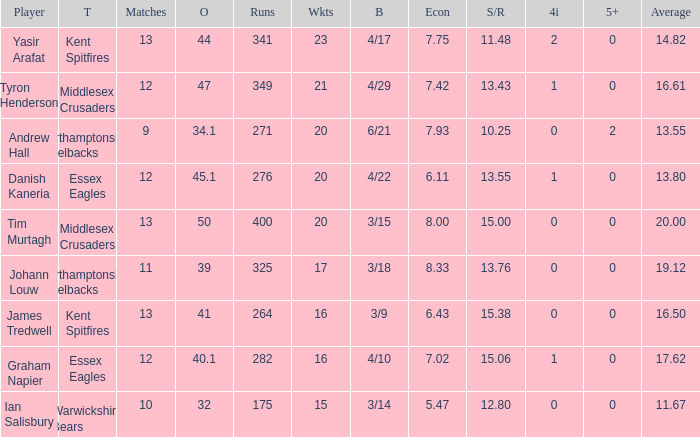What are the top four innings? 2.0. 